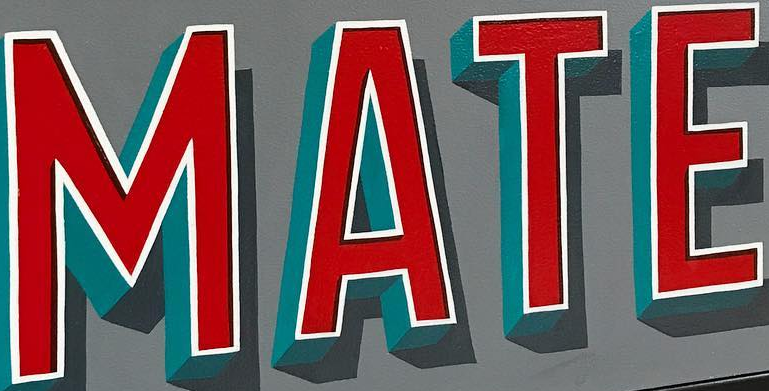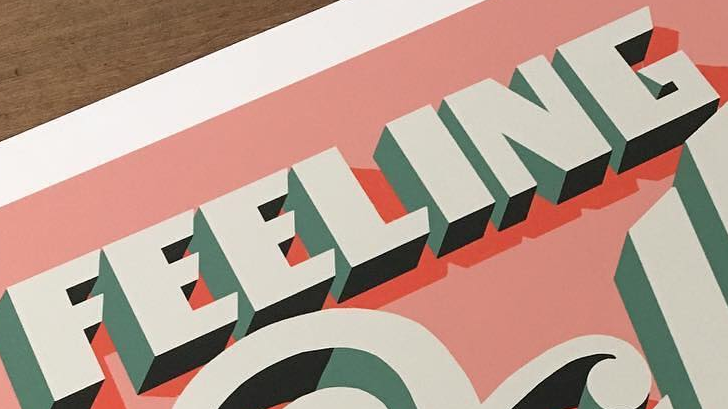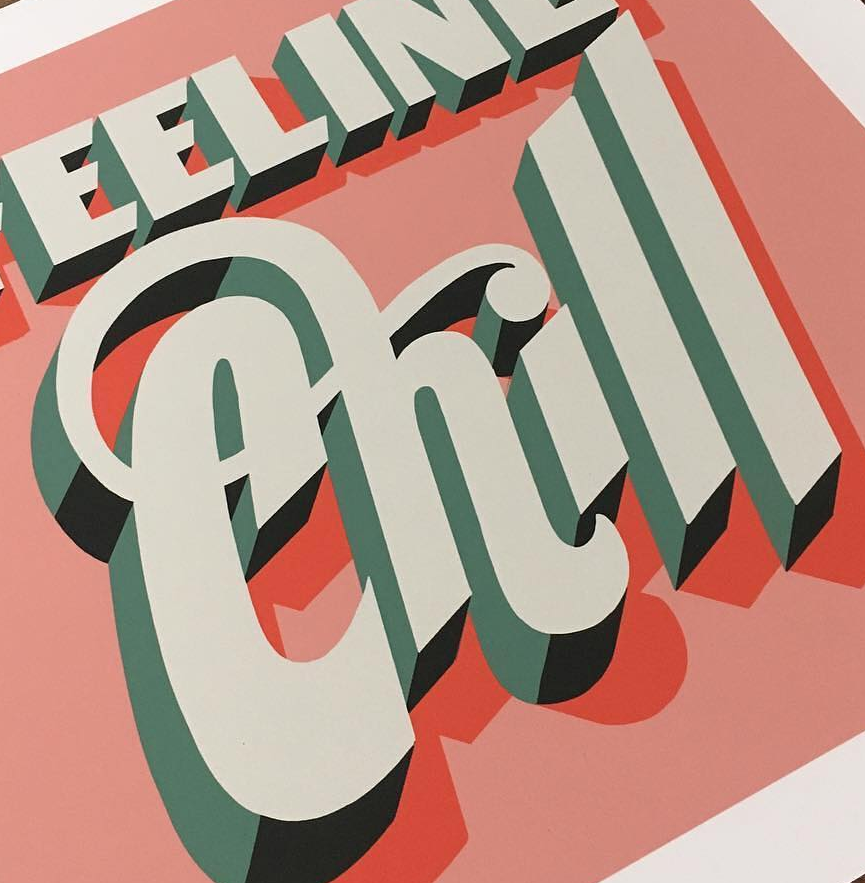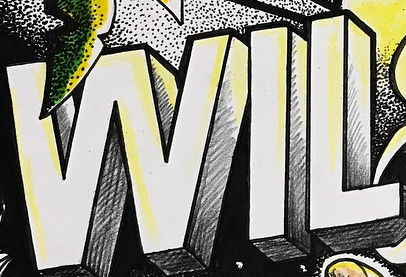What words are shown in these images in order, separated by a semicolon? MATE; FEELING; Chill; WIL 